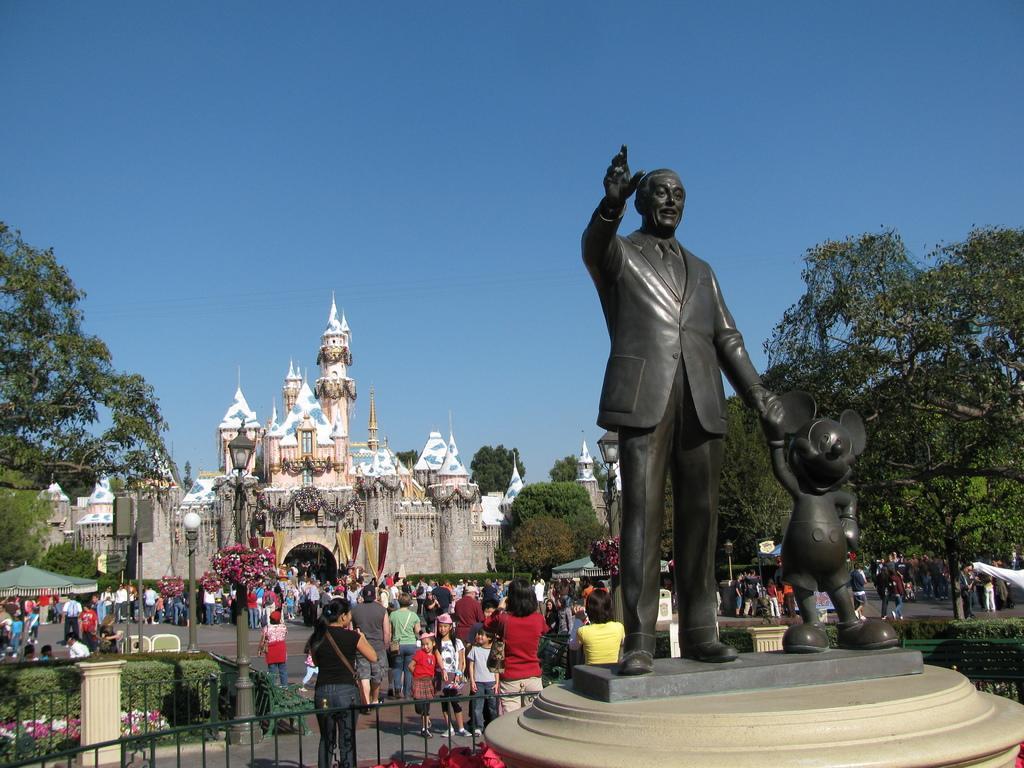Please provide a concise description of this image. In this image I can see few trees, black color statues, fencing, buildings, light poles, tents, few colorful flowers and few people around. The sky is in blue color. 